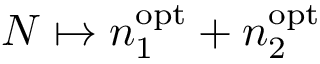<formula> <loc_0><loc_0><loc_500><loc_500>N \mapsto n _ { 1 } ^ { o p t } + n _ { 2 } ^ { o p t }</formula> 